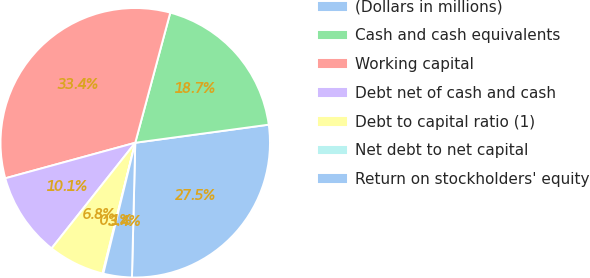Convert chart. <chart><loc_0><loc_0><loc_500><loc_500><pie_chart><fcel>(Dollars in millions)<fcel>Cash and cash equivalents<fcel>Working capital<fcel>Debt net of cash and cash<fcel>Debt to capital ratio (1)<fcel>Net debt to net capital<fcel>Return on stockholders' equity<nl><fcel>27.53%<fcel>18.67%<fcel>33.43%<fcel>10.09%<fcel>6.76%<fcel>0.09%<fcel>3.42%<nl></chart> 